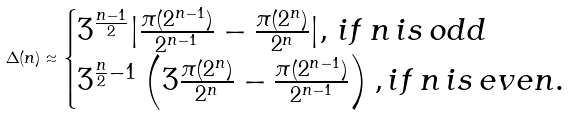Convert formula to latex. <formula><loc_0><loc_0><loc_500><loc_500>\Delta ( n ) \approx \begin{cases} 3 ^ { \frac { n - 1 } { 2 } } | \frac { \pi ( 2 ^ { n - 1 } ) } { 2 ^ { n - 1 } } - \frac { \pi ( 2 ^ { n } ) } { 2 ^ { n } } | , \, i f \, n \, i s \, o d d \\ 3 ^ { \frac { n } { 2 } - 1 } \left ( 3 \frac { \pi ( 2 ^ { n } ) } { 2 ^ { n } } - \frac { \pi ( 2 ^ { n - 1 } ) } { 2 ^ { n - 1 } } \right ) , i f \, n \, i s \, e v e n . \end{cases}</formula> 